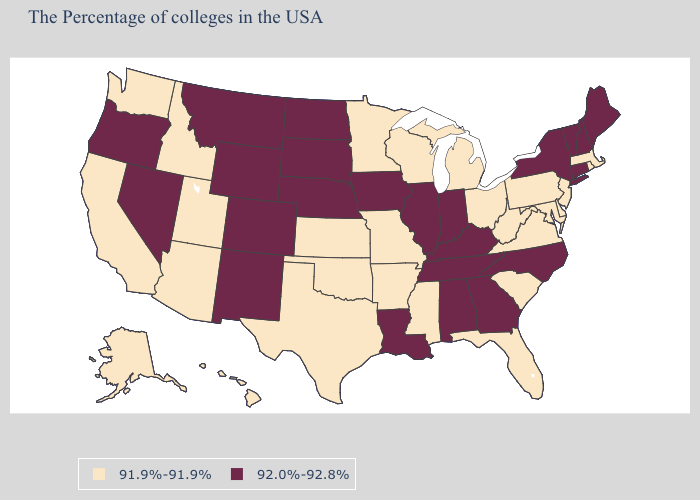What is the value of Alabama?
Write a very short answer. 92.0%-92.8%. Among the states that border Texas , does Arkansas have the highest value?
Write a very short answer. No. Name the states that have a value in the range 91.9%-91.9%?
Answer briefly. Massachusetts, Rhode Island, New Jersey, Delaware, Maryland, Pennsylvania, Virginia, South Carolina, West Virginia, Ohio, Florida, Michigan, Wisconsin, Mississippi, Missouri, Arkansas, Minnesota, Kansas, Oklahoma, Texas, Utah, Arizona, Idaho, California, Washington, Alaska, Hawaii. How many symbols are there in the legend?
Quick response, please. 2. Which states have the lowest value in the South?
Give a very brief answer. Delaware, Maryland, Virginia, South Carolina, West Virginia, Florida, Mississippi, Arkansas, Oklahoma, Texas. What is the lowest value in the USA?
Keep it brief. 91.9%-91.9%. What is the value of Vermont?
Quick response, please. 92.0%-92.8%. Is the legend a continuous bar?
Keep it brief. No. What is the value of Missouri?
Concise answer only. 91.9%-91.9%. How many symbols are there in the legend?
Keep it brief. 2. Among the states that border Washington , which have the lowest value?
Give a very brief answer. Idaho. Does Mississippi have the lowest value in the USA?
Write a very short answer. Yes. Which states have the highest value in the USA?
Give a very brief answer. Maine, New Hampshire, Vermont, Connecticut, New York, North Carolina, Georgia, Kentucky, Indiana, Alabama, Tennessee, Illinois, Louisiana, Iowa, Nebraska, South Dakota, North Dakota, Wyoming, Colorado, New Mexico, Montana, Nevada, Oregon. Among the states that border Oklahoma , does Texas have the lowest value?
Quick response, please. Yes. Name the states that have a value in the range 91.9%-91.9%?
Be succinct. Massachusetts, Rhode Island, New Jersey, Delaware, Maryland, Pennsylvania, Virginia, South Carolina, West Virginia, Ohio, Florida, Michigan, Wisconsin, Mississippi, Missouri, Arkansas, Minnesota, Kansas, Oklahoma, Texas, Utah, Arizona, Idaho, California, Washington, Alaska, Hawaii. 